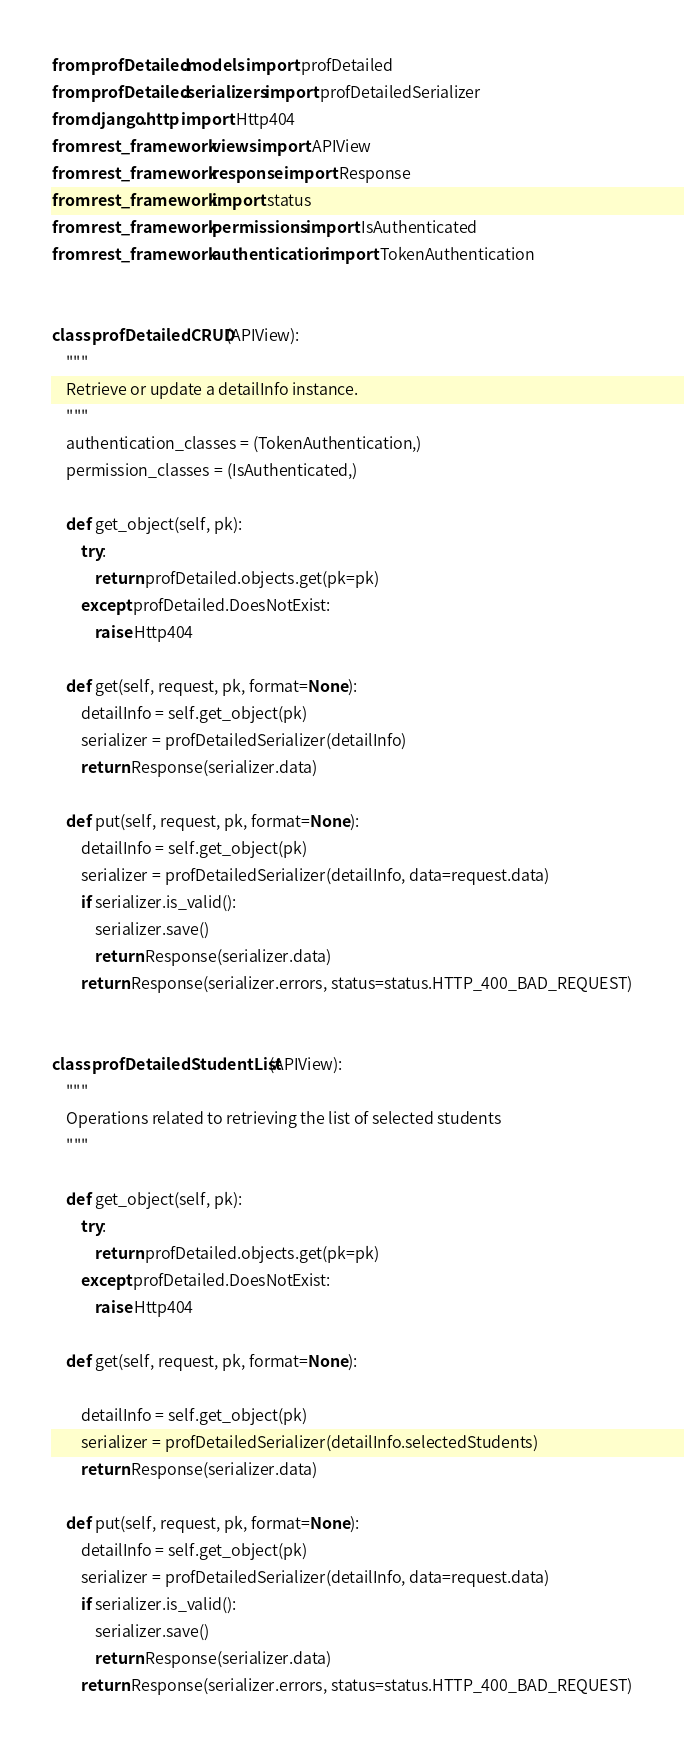<code> <loc_0><loc_0><loc_500><loc_500><_Python_>from profDetailed.models import profDetailed
from profDetailed.serializers import profDetailedSerializer
from django.http import Http404
from rest_framework.views import APIView
from rest_framework.response import Response
from rest_framework import status
from rest_framework.permissions import IsAuthenticated
from rest_framework.authentication import TokenAuthentication


class profDetailedCRUD(APIView):
    """
    Retrieve or update a detailInfo instance.
    """
    authentication_classes = (TokenAuthentication,)
    permission_classes = (IsAuthenticated,)
    
    def get_object(self, pk):
        try:
            return profDetailed.objects.get(pk=pk)
        except profDetailed.DoesNotExist:
            raise Http404

    def get(self, request, pk, format=None):
        detailInfo = self.get_object(pk)
        serializer = profDetailedSerializer(detailInfo)
        return Response(serializer.data)

    def put(self, request, pk, format=None):
        detailInfo = self.get_object(pk)
        serializer = profDetailedSerializer(detailInfo, data=request.data)
        if serializer.is_valid():
            serializer.save()
            return Response(serializer.data)
        return Response(serializer.errors, status=status.HTTP_400_BAD_REQUEST)


class profDetailedStudentList(APIView):
    """
    Operations related to retrieving the list of selected students
    """

    def get_object(self, pk):
        try:
            return profDetailed.objects.get(pk=pk)
        except profDetailed.DoesNotExist:
            raise Http404

    def get(self, request, pk, format=None):

        detailInfo = self.get_object(pk)
        serializer = profDetailedSerializer(detailInfo.selectedStudents)
        return Response(serializer.data)

    def put(self, request, pk, format=None):
        detailInfo = self.get_object(pk)
        serializer = profDetailedSerializer(detailInfo, data=request.data)
        if serializer.is_valid():
            serializer.save()
            return Response(serializer.data)
        return Response(serializer.errors, status=status.HTTP_400_BAD_REQUEST)
</code> 